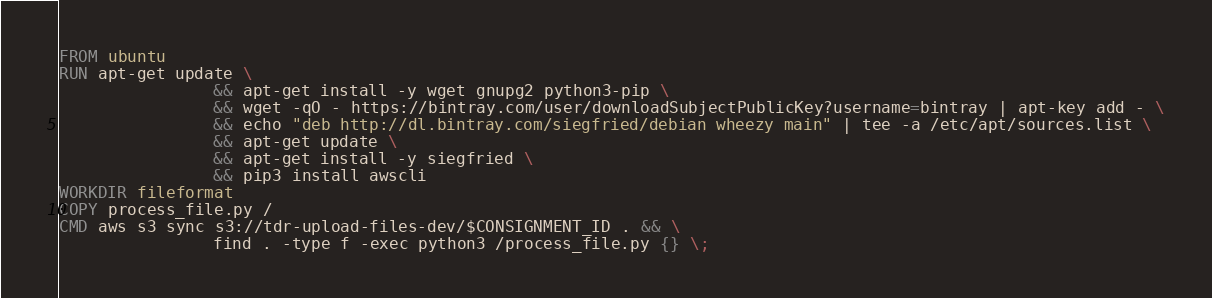Convert code to text. <code><loc_0><loc_0><loc_500><loc_500><_Dockerfile_>FROM ubuntu
RUN apt-get update \
                && apt-get install -y wget gnupg2 python3-pip \
                && wget -qO - https://bintray.com/user/downloadSubjectPublicKey?username=bintray | apt-key add - \
                && echo "deb http://dl.bintray.com/siegfried/debian wheezy main" | tee -a /etc/apt/sources.list \
                && apt-get update \
                && apt-get install -y siegfried \
                && pip3 install awscli
WORKDIR fileformat
COPY process_file.py /
CMD aws s3 sync s3://tdr-upload-files-dev/$CONSIGNMENT_ID . && \
				find . -type f -exec python3 /process_file.py {} \;


</code> 